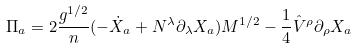<formula> <loc_0><loc_0><loc_500><loc_500>\Pi _ { a } = 2 \frac { g ^ { 1 / 2 } } { n } ( - \dot { X } _ { a } + N ^ { \lambda } \partial _ { \lambda } X _ { a } ) M ^ { 1 / 2 } - \frac { 1 } { 4 } \hat { V } ^ { \rho } \partial _ { \rho } X _ { a }</formula> 